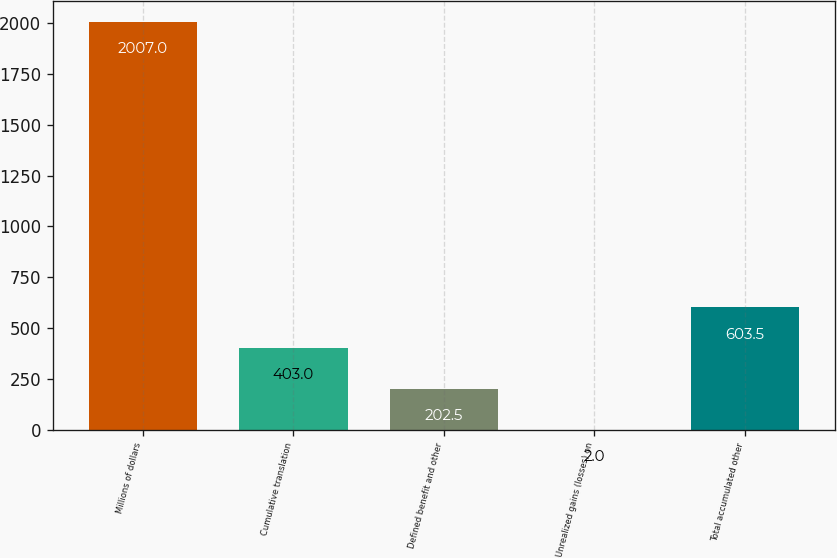Convert chart to OTSL. <chart><loc_0><loc_0><loc_500><loc_500><bar_chart><fcel>Millions of dollars<fcel>Cumulative translation<fcel>Defined benefit and other<fcel>Unrealized gains (losses) on<fcel>Total accumulated other<nl><fcel>2007<fcel>403<fcel>202.5<fcel>2<fcel>603.5<nl></chart> 